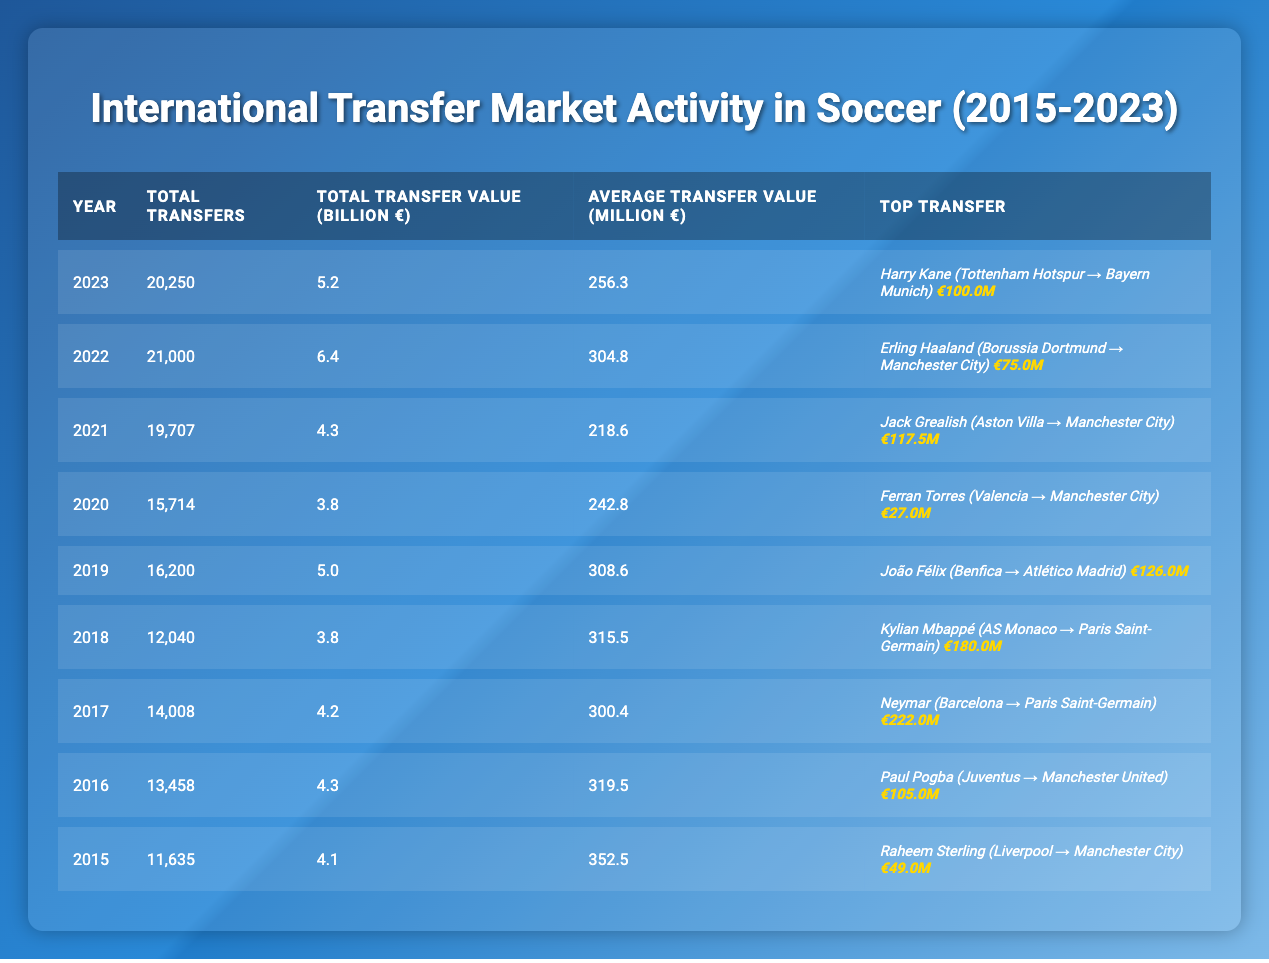What year had the highest total transfers? According to the table, the year with the highest total transfers is 2022, with 21,000 transfers.
Answer: 2022 What was the average transfer value in 2019? The average transfer value for 2019, as shown in the table, is 308.6 million euros.
Answer: 308.6 million euros How much was the top transfer value in 2017? The table indicates that the top transfer in 2017 was Neymar's transfer from Barcelona to Paris Saint-Germain, valued at 222.0 million euros.
Answer: 222.0 million euros Which year saw the lowest average transfer value? In the table, the lowest average transfer value is in 2021, which is 218.6 million euros.
Answer: 2021 Was the total transfer value greater in 2023 than in 2022? Based on the table, the total transfer value in 2023 is 5.2 billion euros, which is less than the 6.4 billion euros recorded in 2022. Thus, the statement is false.
Answer: No What was the percentage increase in total transfers from 2015 to 2022? From 2015 to 2022, the total transfers increased from 11,635 to 21,000. The difference is 21,000 - 11,635 = 9,365, and the percentage increase is (9,365 / 11,635) * 100 ≈ 80.4%.
Answer: Approximately 80.4% Which player had the highest transfer value in the provided data? The table shows that Neymar had the highest transfer value at 222.0 million euros in 2017.
Answer: Neymar How does the total transfer value in 2020 compare to that in 2018? The total transfer value in 2020 is 3.8 billion euros, while in 2018, it was also 3.8 billion euros. Therefore, they are equal.
Answer: They are equal What is the trend of average transfer value from 2015 to 2023? Analyzing the average transfer values from the years: 352.5 (2015), 319.5 (2016), 300.4 (2017), 315.5 (2018), 308.6 (2019), 242.8 (2020), 218.6 (2021), 304.8 (2022), and 256.3 (2023), we can see a decline initially, a slight recovery, and a peak in 2022 before decreasing again in 2023.
Answer: Fluctuating trend, initially declining What club is associated with the most expensive transfer in the data? The club associated with the most expensive transfer is Paris Saint-Germain, as it acquired Neymar from Barcelona for 222.0 million euros in 2017.
Answer: Paris Saint-Germain 